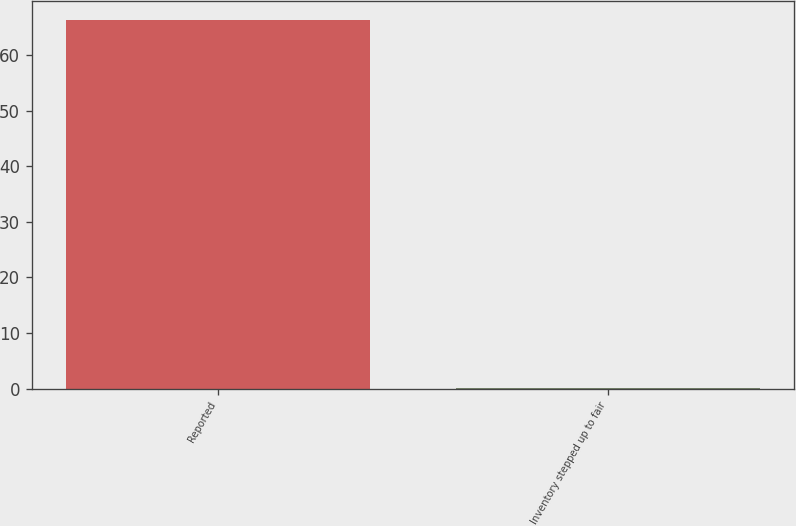Convert chart. <chart><loc_0><loc_0><loc_500><loc_500><bar_chart><fcel>Reported<fcel>Inventory stepped up to fair<nl><fcel>66.4<fcel>0.1<nl></chart> 